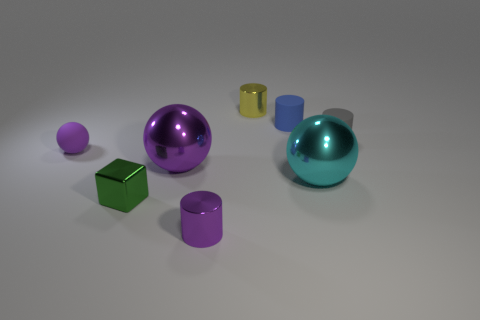Is there anything else that has the same shape as the green metallic object?
Your answer should be compact. No. What is the color of the metallic sphere that is on the left side of the metallic cylinder that is behind the small rubber thing that is left of the small yellow metallic object?
Provide a short and direct response. Purple. The small rubber ball has what color?
Provide a short and direct response. Purple. Are there more tiny yellow cylinders on the right side of the large cyan object than blue matte cylinders that are in front of the big purple shiny object?
Your response must be concise. No. There is a small yellow thing; is it the same shape as the small purple thing that is on the right side of the tiny ball?
Your answer should be compact. Yes. There is a matte cylinder that is in front of the blue object; is it the same size as the metallic cylinder behind the tiny purple rubber thing?
Provide a succinct answer. Yes. There is a tiny green shiny block on the left side of the shiny cylinder that is in front of the big cyan sphere; are there any small metal things that are in front of it?
Offer a terse response. Yes. Are there fewer gray cylinders to the right of the small blue cylinder than tiny green shiny objects on the left side of the cube?
Your response must be concise. No. There is a green thing that is the same material as the small yellow thing; what is its shape?
Your answer should be compact. Cube. There is a purple ball to the right of the tiny purple object that is on the left side of the small cylinder that is in front of the gray cylinder; what is its size?
Offer a very short reply. Large. 